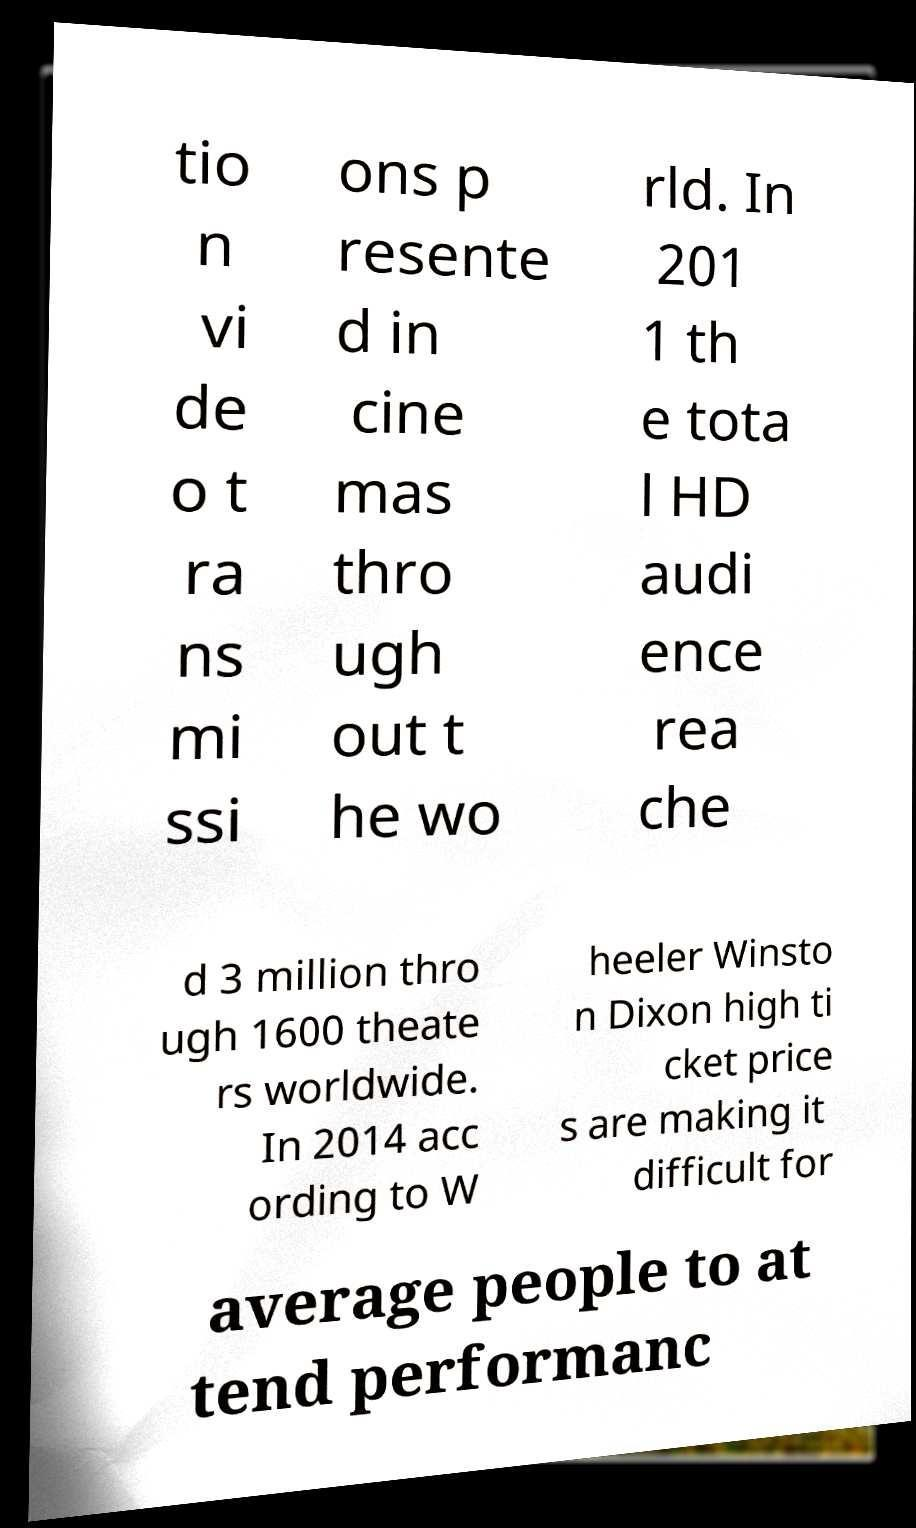Could you extract and type out the text from this image? tio n vi de o t ra ns mi ssi ons p resente d in cine mas thro ugh out t he wo rld. In 201 1 th e tota l HD audi ence rea che d 3 million thro ugh 1600 theate rs worldwide. In 2014 acc ording to W heeler Winsto n Dixon high ti cket price s are making it difficult for average people to at tend performanc 